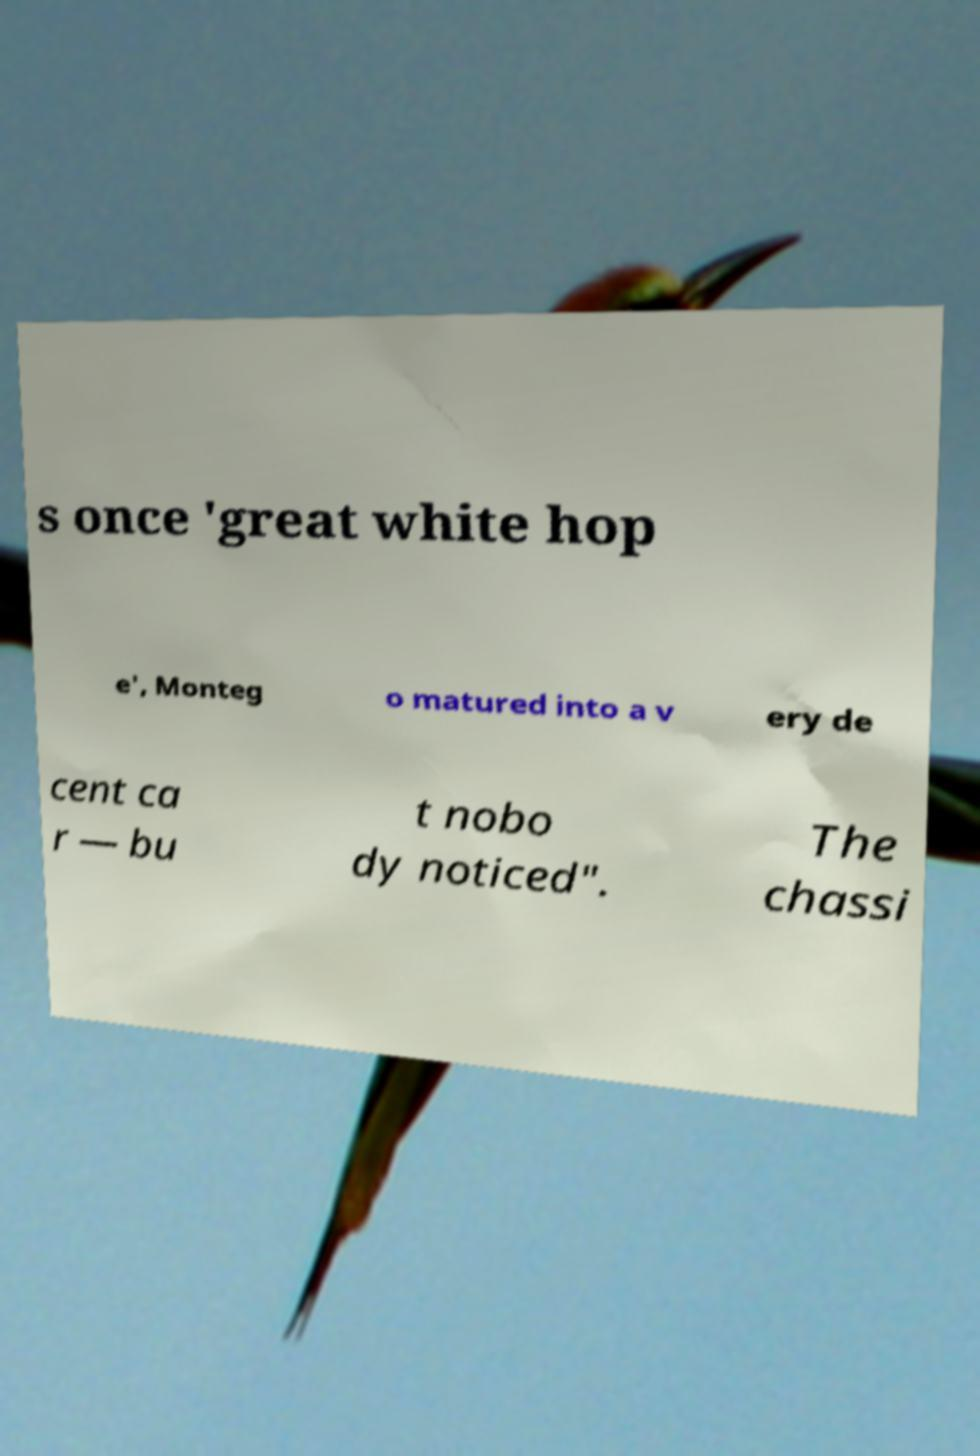Please identify and transcribe the text found in this image. s once 'great white hop e', Monteg o matured into a v ery de cent ca r — bu t nobo dy noticed". The chassi 